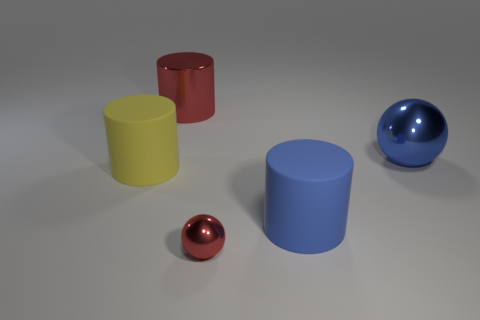Add 3 small red balls. How many objects exist? 8 Subtract all cylinders. How many objects are left? 2 Subtract all red shiny cylinders. Subtract all red metal spheres. How many objects are left? 3 Add 4 small balls. How many small balls are left? 5 Add 5 matte objects. How many matte objects exist? 7 Subtract 0 green cylinders. How many objects are left? 5 